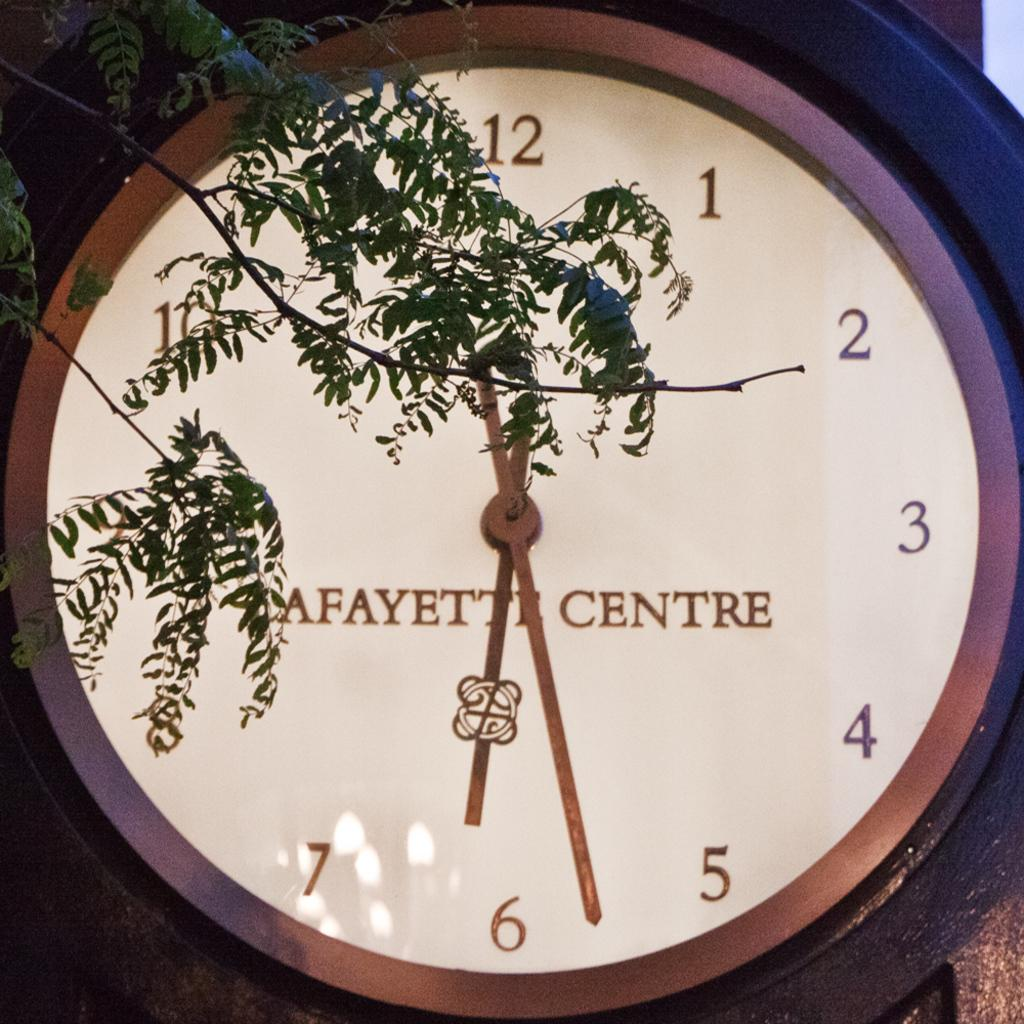<image>
Write a terse but informative summary of the picture. A large clock with LAFAYETTE CENTRE written on it, with a tree branch hanging in front of it. 